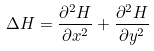Convert formula to latex. <formula><loc_0><loc_0><loc_500><loc_500>\Delta H = \frac { \partial ^ { 2 } H } { \partial x ^ { 2 } } + \frac { \partial ^ { 2 } H } { \partial y ^ { 2 } }</formula> 